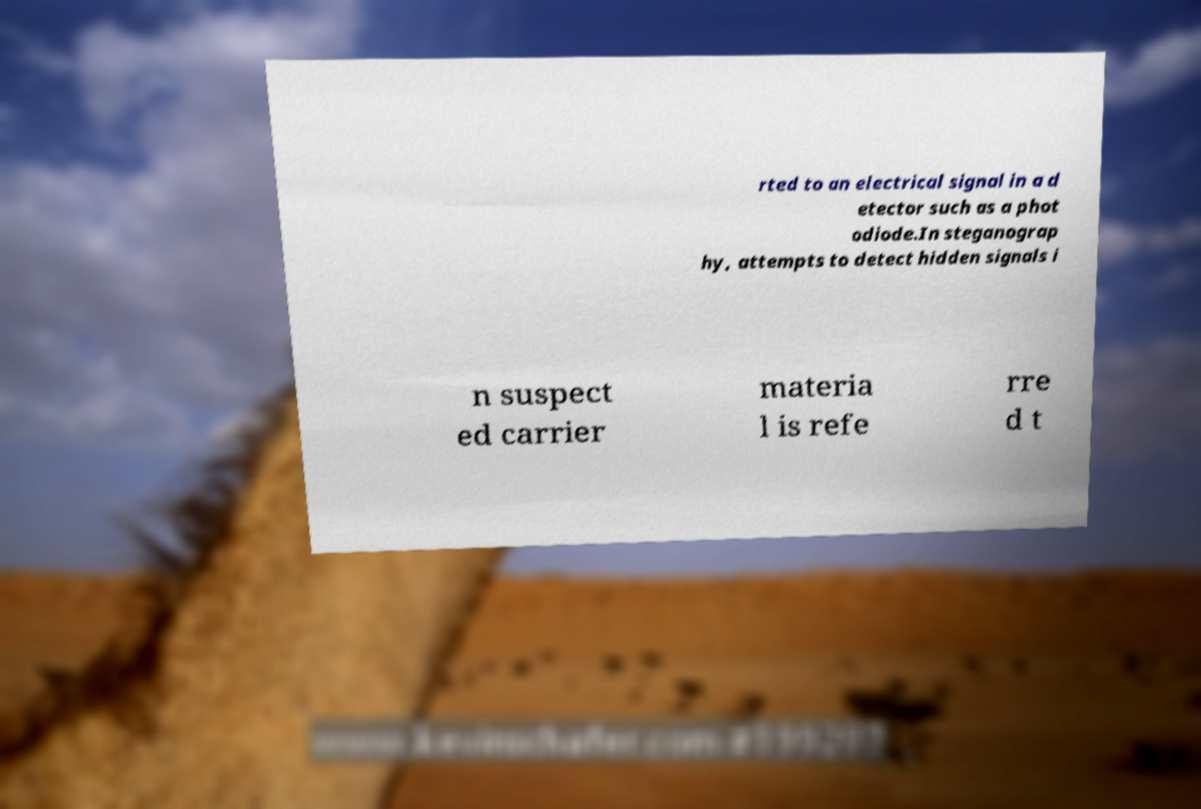Can you accurately transcribe the text from the provided image for me? rted to an electrical signal in a d etector such as a phot odiode.In steganograp hy, attempts to detect hidden signals i n suspect ed carrier materia l is refe rre d t 